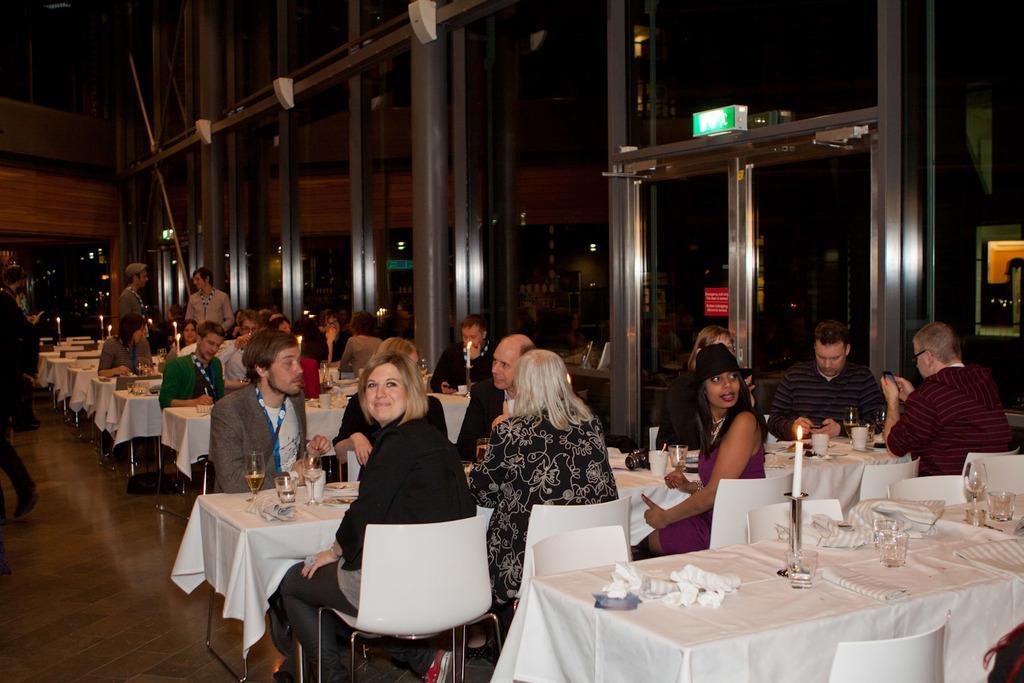In one or two sentences, can you explain what this image depicts? The picture is clicked in a restaurant where people are sitting on white tables and on top of which food eatables are placed. In the background we observe glass door and windows. 